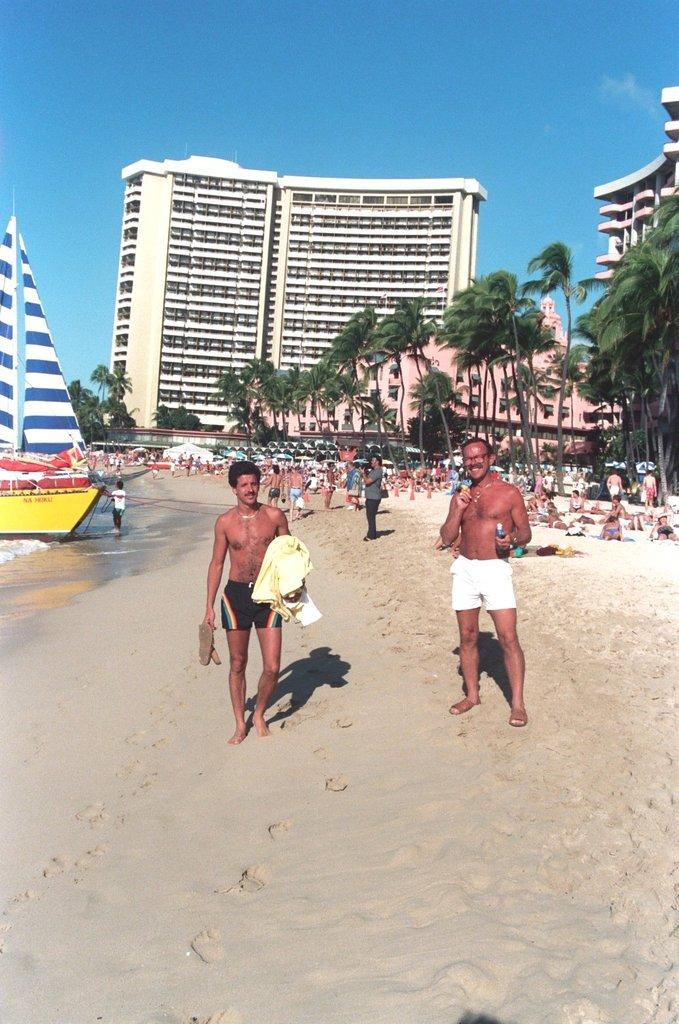What are the people in the image doing? The people in the image are walking on the sand. What can be seen in the background of the image? There are trees, people, a ship, buildings, and the sky visible in the background. How many elements can be seen in the background of the image? There are five elements visible in the background: trees, people, a ship, buildings, and the sky. Where are the rabbits hiding in the image? There are no rabbits present in the image. What type of mask is being worn by the people in the image? There is no mention of masks in the image, as the people are walking on the sand without any visible masks. 